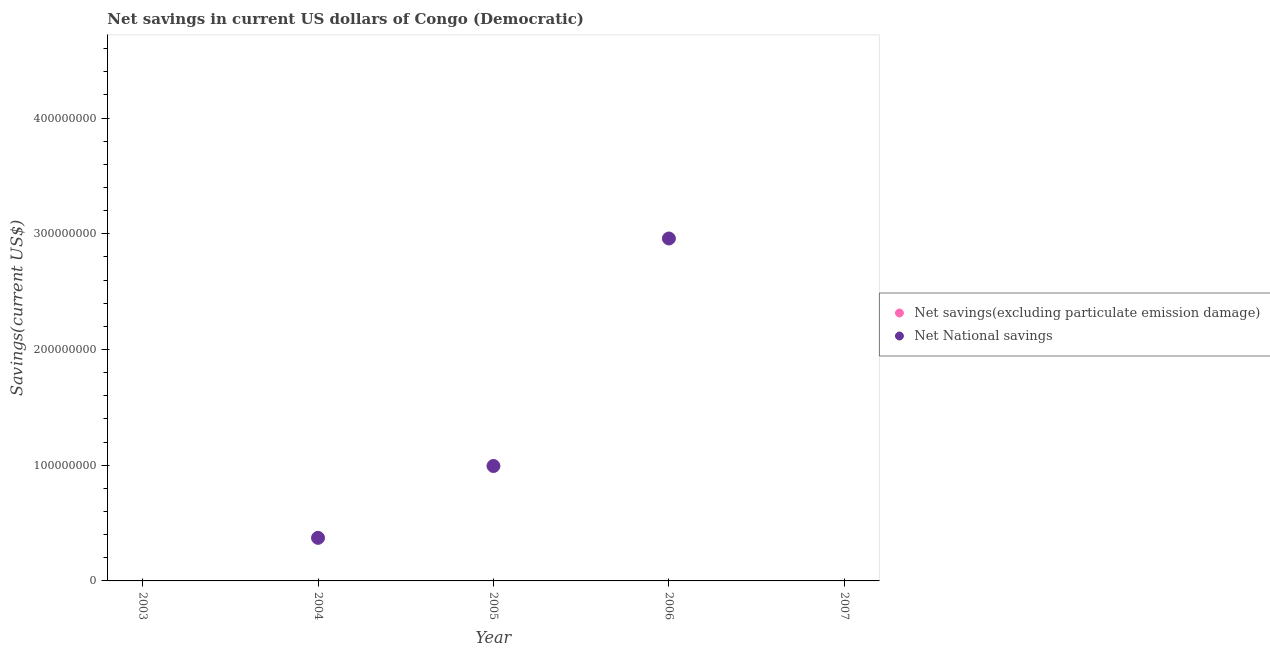Is the number of dotlines equal to the number of legend labels?
Give a very brief answer. No. What is the net national savings in 2005?
Provide a succinct answer. 9.93e+07. Across all years, what is the maximum net national savings?
Your answer should be compact. 2.96e+08. In which year was the net national savings maximum?
Make the answer very short. 2006. What is the total net savings(excluding particulate emission damage) in the graph?
Your response must be concise. 0. What is the difference between the net national savings in 2005 and that in 2006?
Offer a terse response. -1.97e+08. What is the difference between the net national savings in 2006 and the net savings(excluding particulate emission damage) in 2005?
Your answer should be compact. 2.96e+08. In how many years, is the net national savings greater than 360000000 US$?
Ensure brevity in your answer.  0. What is the ratio of the net national savings in 2004 to that in 2006?
Provide a succinct answer. 0.13. What is the difference between the highest and the second highest net national savings?
Ensure brevity in your answer.  1.97e+08. In how many years, is the net national savings greater than the average net national savings taken over all years?
Offer a terse response. 2. Is the net savings(excluding particulate emission damage) strictly less than the net national savings over the years?
Provide a short and direct response. Yes. How many dotlines are there?
Your response must be concise. 1. What is the difference between two consecutive major ticks on the Y-axis?
Provide a short and direct response. 1.00e+08. Are the values on the major ticks of Y-axis written in scientific E-notation?
Ensure brevity in your answer.  No. How many legend labels are there?
Provide a short and direct response. 2. What is the title of the graph?
Your answer should be very brief. Net savings in current US dollars of Congo (Democratic). Does "Register a business" appear as one of the legend labels in the graph?
Ensure brevity in your answer.  No. What is the label or title of the Y-axis?
Offer a very short reply. Savings(current US$). What is the Savings(current US$) of Net savings(excluding particulate emission damage) in 2003?
Your answer should be very brief. 0. What is the Savings(current US$) of Net National savings in 2004?
Offer a very short reply. 3.72e+07. What is the Savings(current US$) of Net National savings in 2005?
Provide a short and direct response. 9.93e+07. What is the Savings(current US$) of Net National savings in 2006?
Make the answer very short. 2.96e+08. Across all years, what is the maximum Savings(current US$) in Net National savings?
Your answer should be very brief. 2.96e+08. Across all years, what is the minimum Savings(current US$) of Net National savings?
Your answer should be compact. 0. What is the total Savings(current US$) in Net savings(excluding particulate emission damage) in the graph?
Your answer should be compact. 0. What is the total Savings(current US$) in Net National savings in the graph?
Your answer should be very brief. 4.33e+08. What is the difference between the Savings(current US$) in Net National savings in 2004 and that in 2005?
Provide a short and direct response. -6.21e+07. What is the difference between the Savings(current US$) in Net National savings in 2004 and that in 2006?
Provide a short and direct response. -2.59e+08. What is the difference between the Savings(current US$) in Net National savings in 2005 and that in 2006?
Make the answer very short. -1.97e+08. What is the average Savings(current US$) in Net National savings per year?
Keep it short and to the point. 8.65e+07. What is the ratio of the Savings(current US$) in Net National savings in 2004 to that in 2005?
Your answer should be compact. 0.37. What is the ratio of the Savings(current US$) of Net National savings in 2004 to that in 2006?
Make the answer very short. 0.13. What is the ratio of the Savings(current US$) in Net National savings in 2005 to that in 2006?
Provide a succinct answer. 0.34. What is the difference between the highest and the second highest Savings(current US$) in Net National savings?
Give a very brief answer. 1.97e+08. What is the difference between the highest and the lowest Savings(current US$) in Net National savings?
Make the answer very short. 2.96e+08. 